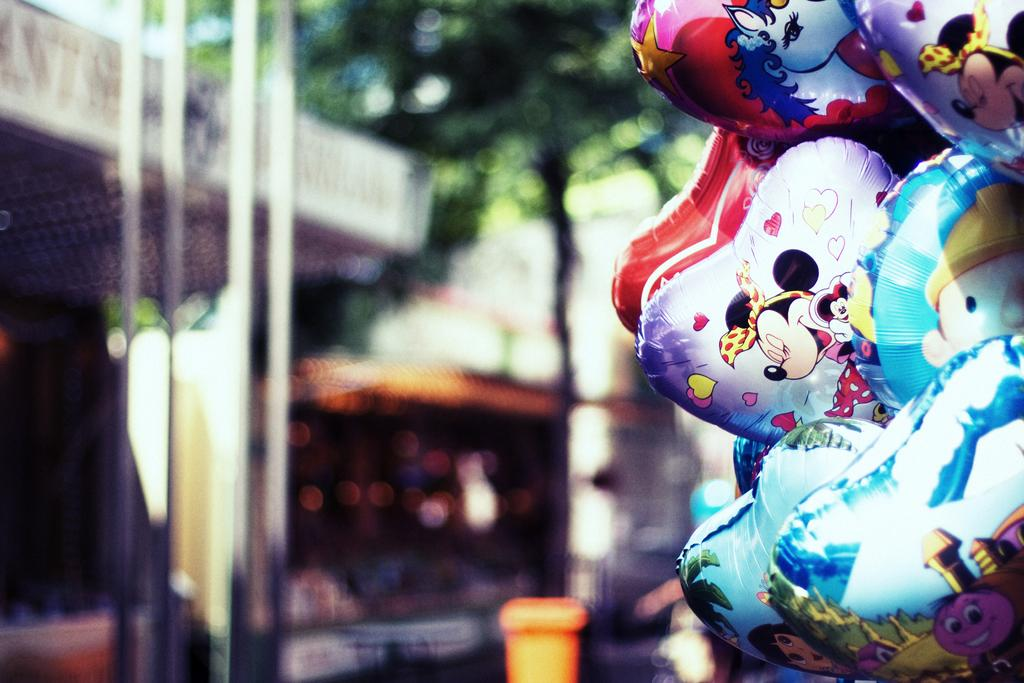What objects are present in the image? There are balloons in the image. Can you describe the background of the image? The background of the image is blurry. What type of waste can be seen in the image? There is no waste present in the image; it only features balloons. Can you describe the plants in the image? There are no plants present in the image. 